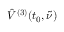Convert formula to latex. <formula><loc_0><loc_0><loc_500><loc_500>\hat { V } ^ { ( 3 ) } ( t _ { 0 } , \tilde { \nu } )</formula> 